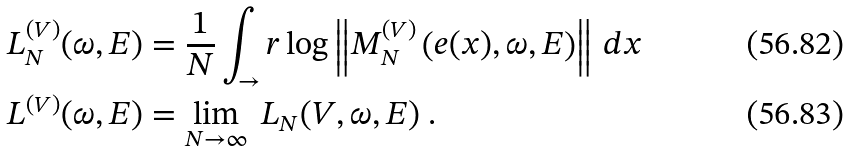Convert formula to latex. <formula><loc_0><loc_0><loc_500><loc_500>L _ { N } ^ { ( V ) } ( \omega , E ) & = \frac { 1 } { N } \int _ { \to } r \log \left \| M _ { N } ^ { ( V ) } \left ( e ( x ) , \omega , E \right ) \right \| \, d x \\ L ^ { ( V ) } ( \omega , E ) & = \lim _ { N \to \infty } \ L _ { N } ( V , \omega , E ) \ .</formula> 